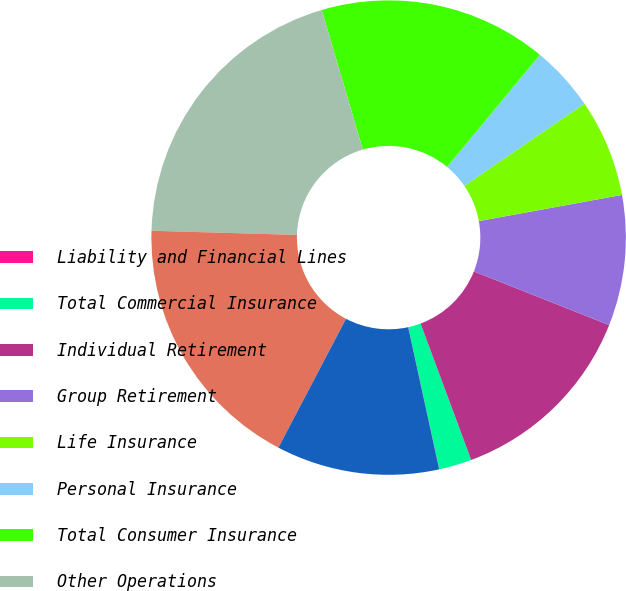<chart> <loc_0><loc_0><loc_500><loc_500><pie_chart><fcel>Liability and Financial Lines<fcel>Total Commercial Insurance<fcel>Individual Retirement<fcel>Group Retirement<fcel>Life Insurance<fcel>Personal Insurance<fcel>Total Consumer Insurance<fcel>Other Operations<fcel>Legacy Portfolio<fcel>AIG Consolidation and<nl><fcel>0.01%<fcel>2.23%<fcel>13.33%<fcel>8.89%<fcel>6.67%<fcel>4.45%<fcel>15.55%<fcel>19.99%<fcel>17.77%<fcel>11.11%<nl></chart> 